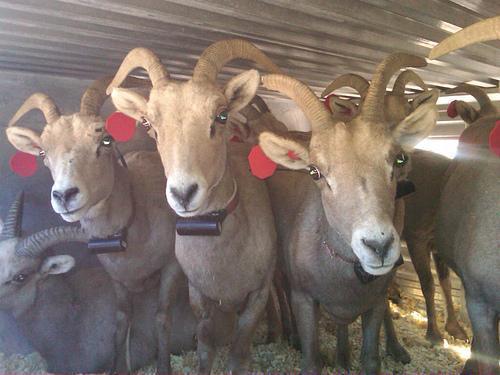How many goats are there?
Give a very brief answer. 5. How many goats are lying down?
Give a very brief answer. 1. 